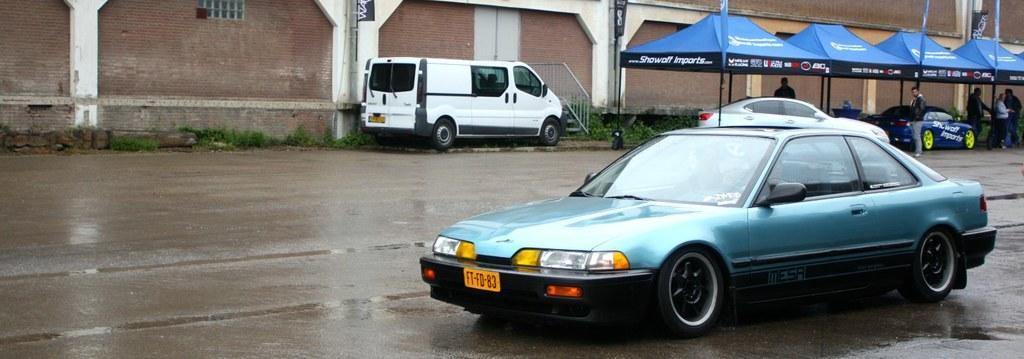Can you describe this image briefly? In this image, we can see some vehicles. There is a wall at the top of the image. There are tents and persons in the top right of the image. 